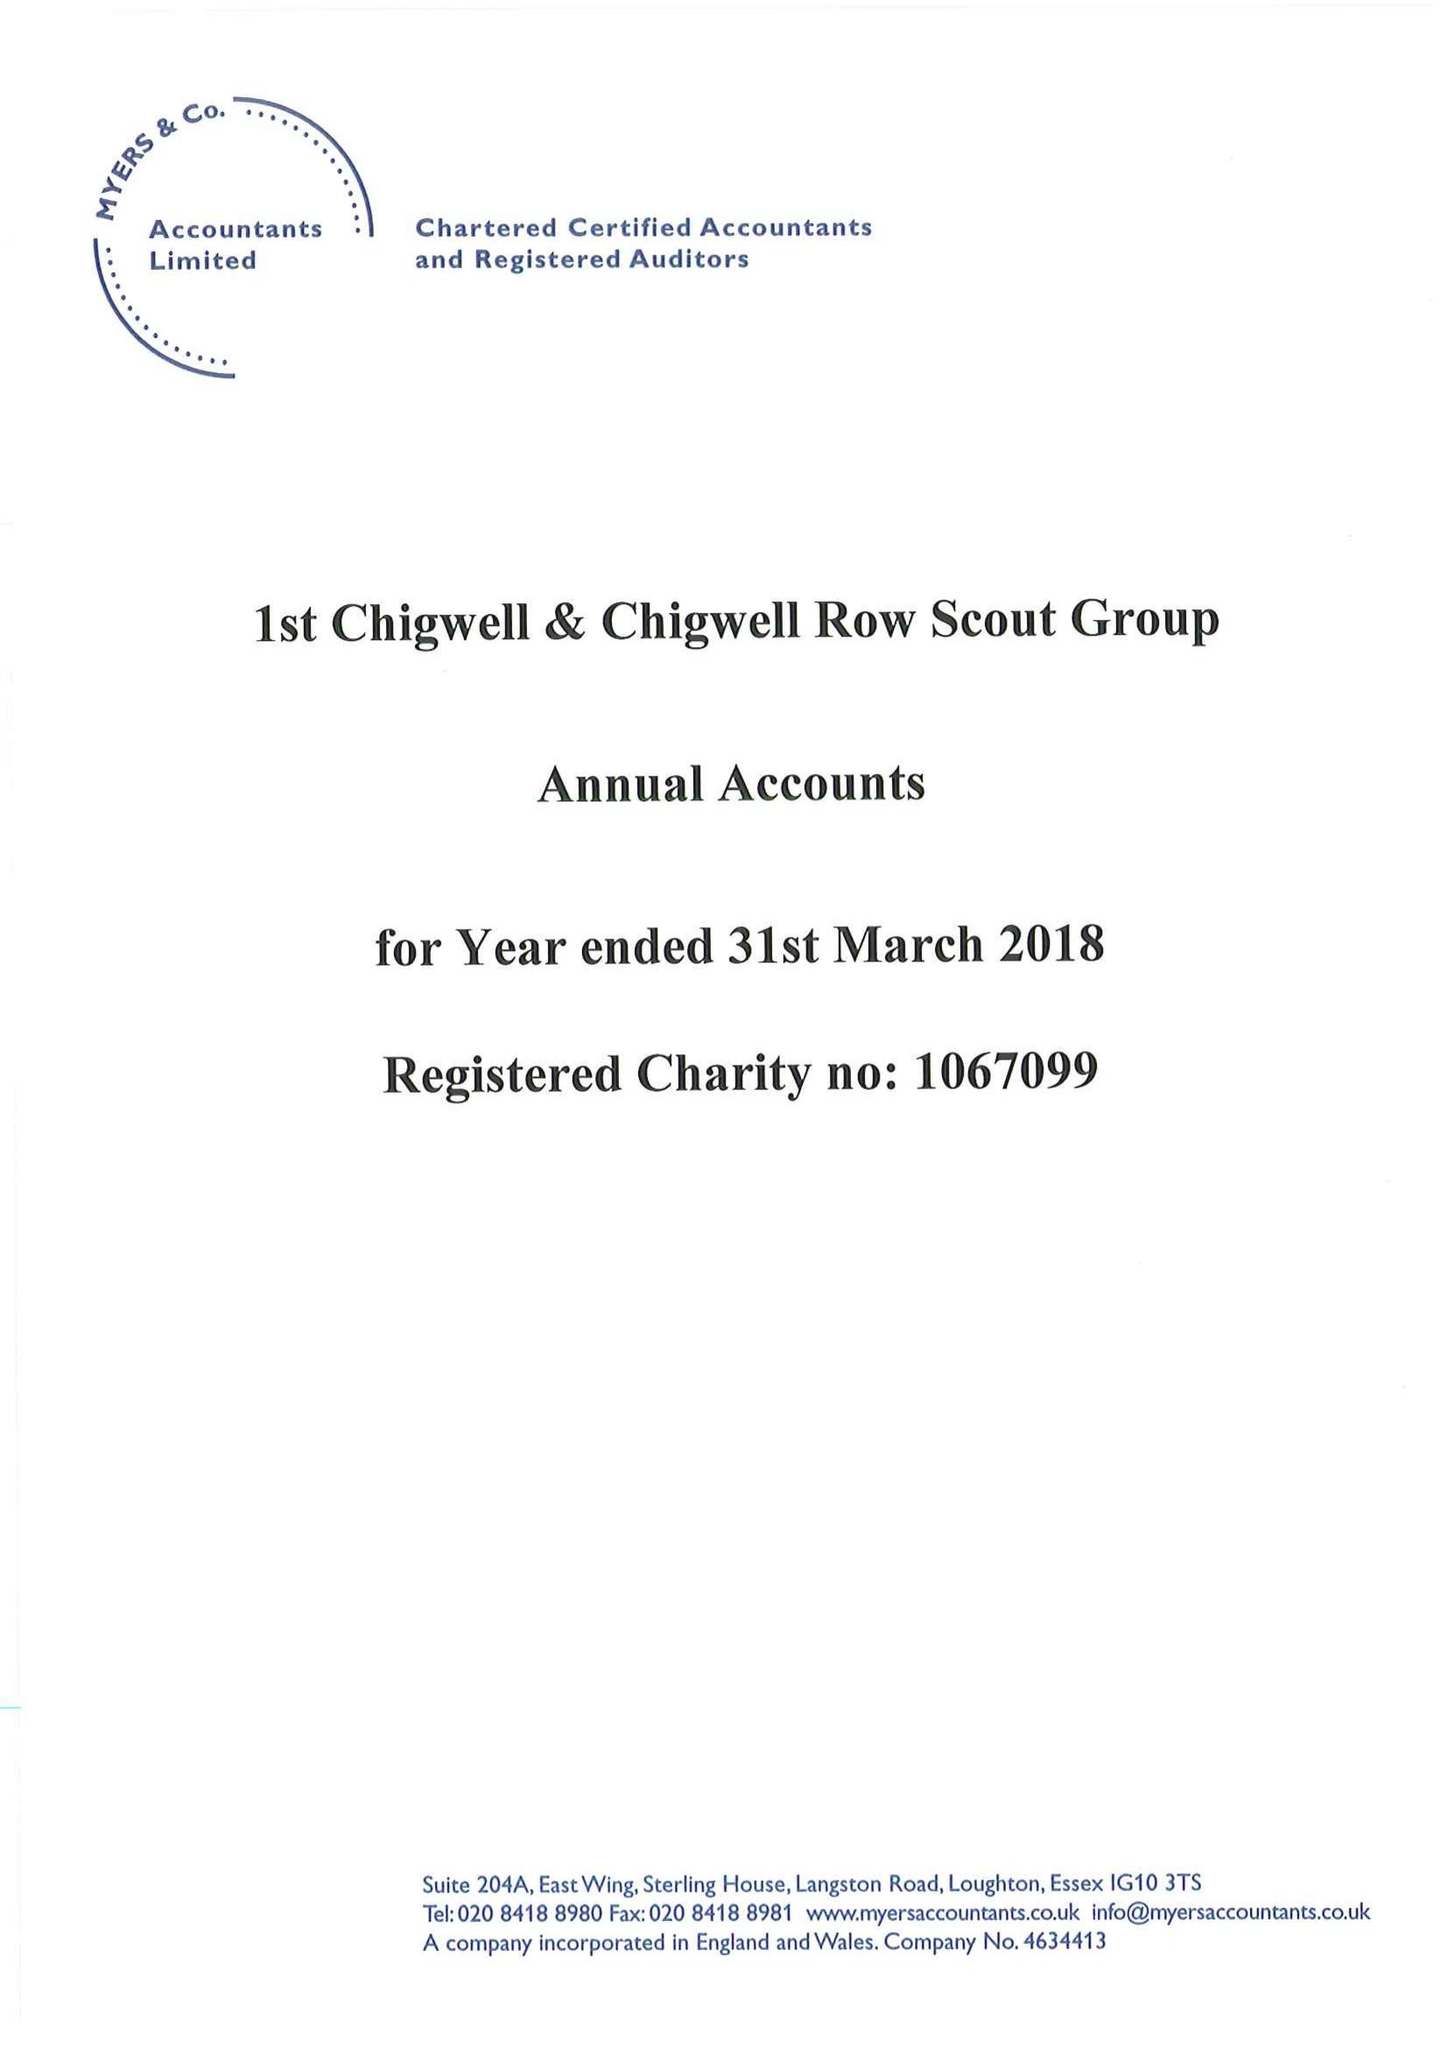What is the value for the income_annually_in_british_pounds?
Answer the question using a single word or phrase. 28234.00 